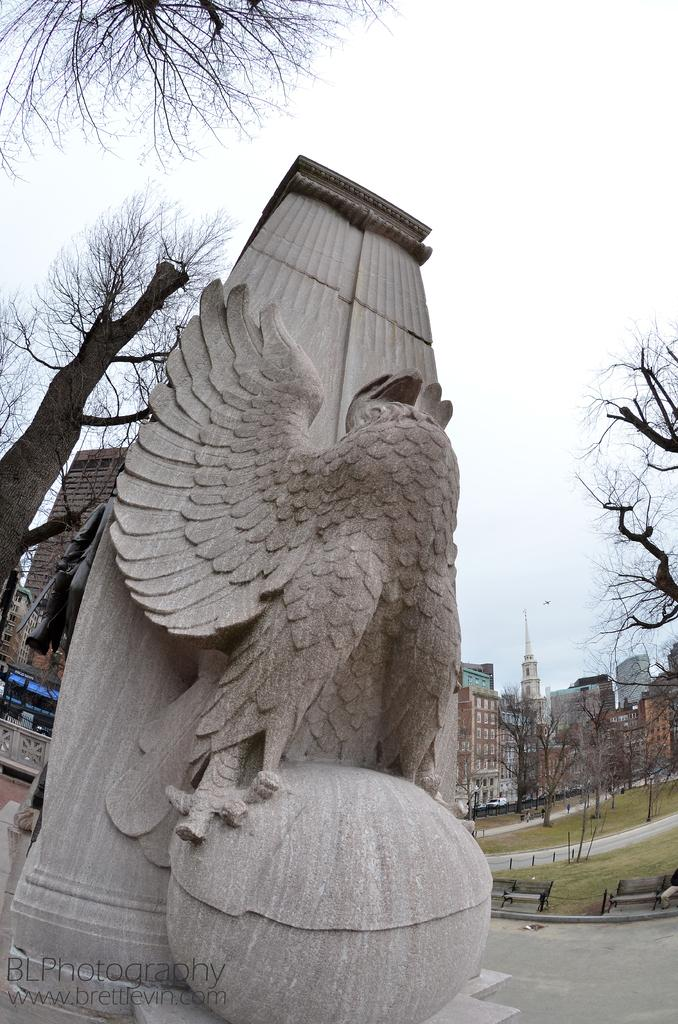What is the main subject of the image? There is a sculpture in the image. What can be seen at the side of the sculpture? There is grass and a bench at the side of the sculpture. What type of vegetation is present in the image? There are trees in the image. What type of structures can be seen in the image? There are buildings in the image. What is visible in the background of the image? The sky is visible in the image. What type of mouth can be seen on the sculpture in the image? There is no mouth present on the sculpture in the image. What type of industry is depicted in the image? The image does not depict any industry; it features a sculpture, grass, a bench, trees, buildings, and the sky. 